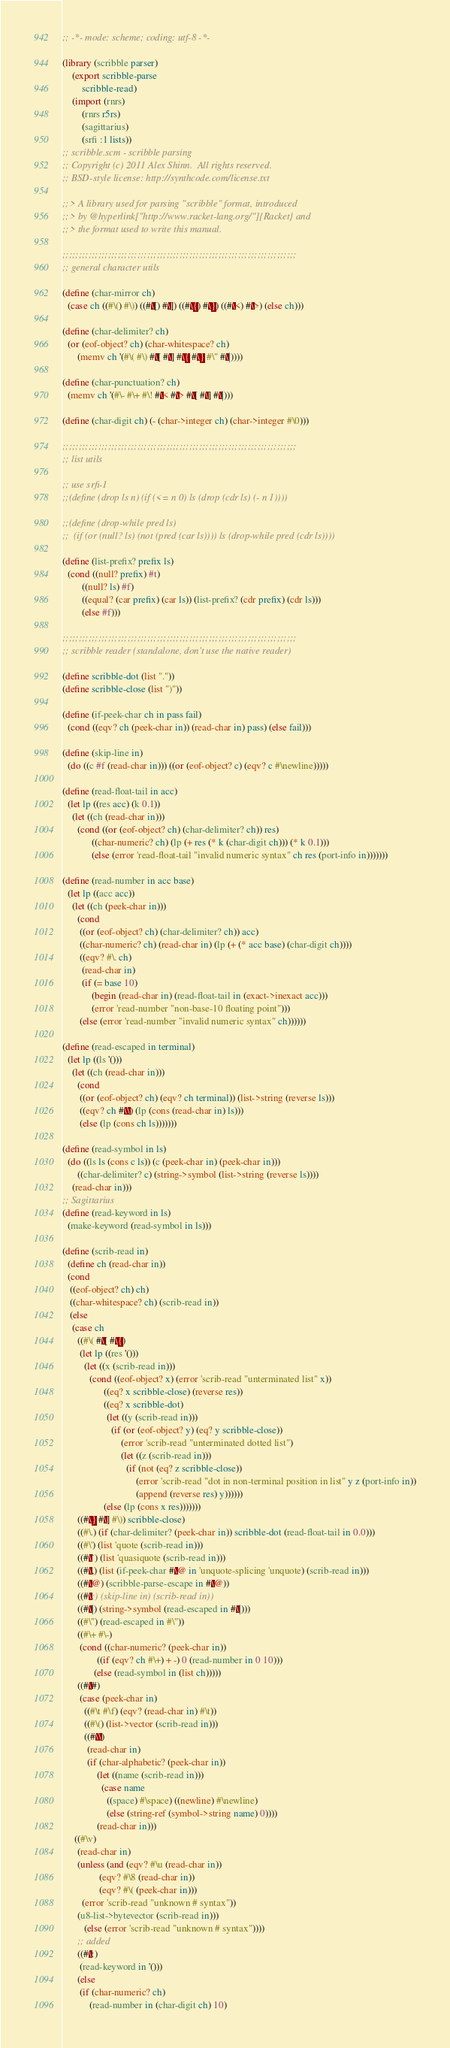<code> <loc_0><loc_0><loc_500><loc_500><_Scheme_>;; -*- mode: scheme; coding: utf-8 -*- 

(library (scribble parser)
    (export scribble-parse
	    scribble-read)
    (import (rnrs)
	    (rnrs r5rs)
	    (sagittarius)
	    (srfi :1 lists))
;; scribble.scm - scribble parsing
;; Copyright (c) 2011 Alex Shinn.  All rights reserved.
;; BSD-style license: http://synthcode.com/license.txt

;;> A library used for parsing "scribble" format, introduced
;;> by @hyperlink["http://www.racket-lang.org/"]{Racket} and
;;> the format used to write this manual.

;;;;;;;;;;;;;;;;;;;;;;;;;;;;;;;;;;;;;;;;;;;;;;;;;;;;;;;;;;;;;;;;;;;;;;;;
;; general character utils

(define (char-mirror ch)
  (case ch ((#\() #\)) ((#\[) #\]) ((#\{) #\}) ((#\<) #\>) (else ch)))

(define (char-delimiter? ch)
  (or (eof-object? ch) (char-whitespace? ch)
      (memv ch '(#\( #\) #\[ #\] #\{ #\} #\" #\|))))

(define (char-punctuation? ch)
  (memv ch '(#\- #\+ #\! #\< #\> #\[ #\] #\|)))

(define (char-digit ch) (- (char->integer ch) (char->integer #\0)))

;;;;;;;;;;;;;;;;;;;;;;;;;;;;;;;;;;;;;;;;;;;;;;;;;;;;;;;;;;;;;;;;;;;;;;;;
;; list utils

;; use srfi-1
;;(define (drop ls n) (if (<= n 0) ls (drop (cdr ls) (- n 1))))

;;(define (drop-while pred ls)
;;  (if (or (null? ls) (not (pred (car ls)))) ls (drop-while pred (cdr ls))))

(define (list-prefix? prefix ls)
  (cond ((null? prefix) #t)
        ((null? ls) #f)
        ((equal? (car prefix) (car ls)) (list-prefix? (cdr prefix) (cdr ls)))
        (else #f)))

;;;;;;;;;;;;;;;;;;;;;;;;;;;;;;;;;;;;;;;;;;;;;;;;;;;;;;;;;;;;;;;;;;;;;;;;
;; scribble reader (standalone, don't use the native reader)

(define scribble-dot (list "."))
(define scribble-close (list ")"))

(define (if-peek-char ch in pass fail)
  (cond ((eqv? ch (peek-char in)) (read-char in) pass) (else fail)))

(define (skip-line in)
  (do ((c #f (read-char in))) ((or (eof-object? c) (eqv? c #\newline)))))

(define (read-float-tail in acc)
  (let lp ((res acc) (k 0.1))
    (let ((ch (read-char in)))
      (cond ((or (eof-object? ch) (char-delimiter? ch)) res)
            ((char-numeric? ch) (lp (+ res (* k (char-digit ch))) (* k 0.1)))
            (else (error 'read-float-tail "invalid numeric syntax" ch res (port-info in)))))))

(define (read-number in acc base)
  (let lp ((acc acc))
    (let ((ch (peek-char in)))
      (cond
       ((or (eof-object? ch) (char-delimiter? ch)) acc)
       ((char-numeric? ch) (read-char in) (lp (+ (* acc base) (char-digit ch))))
       ((eqv? #\. ch)
        (read-char in)
        (if (= base 10)
            (begin (read-char in) (read-float-tail in (exact->inexact acc)))
            (error 'read-number "non-base-10 floating point")))
       (else (error 'read-number "invalid numeric syntax" ch))))))

(define (read-escaped in terminal)
  (let lp ((ls '()))
    (let ((ch (read-char in)))
      (cond
       ((or (eof-object? ch) (eqv? ch terminal)) (list->string (reverse ls)))
       ((eqv? ch #\\) (lp (cons (read-char in) ls)))
       (else (lp (cons ch ls)))))))

(define (read-symbol in ls)
  (do ((ls ls (cons c ls)) (c (peek-char in) (peek-char in)))
      ((char-delimiter? c) (string->symbol (list->string (reverse ls))))
    (read-char in)))
;; Sagittarius 
(define (read-keyword in ls)
  (make-keyword (read-symbol in ls)))

(define (scrib-read in)
  (define ch (read-char in))
  (cond
   ((eof-object? ch) ch)
   ((char-whitespace? ch) (scrib-read in))
   (else
    (case ch
      ((#\( #\[ #\{)
       (let lp ((res '()))
         (let ((x (scrib-read in)))
           (cond ((eof-object? x) (error 'scrib-read "unterminated list" x))
                 ((eq? x scribble-close) (reverse res))
                 ((eq? x scribble-dot)
                  (let ((y (scrib-read in)))
                    (if (or (eof-object? y) (eq? y scribble-close))
                        (error 'scrib-read "unterminated dotted list")
                        (let ((z (scrib-read in)))
                          (if (not (eq? z scribble-close))
                              (error 'scrib-read "dot in non-terminal position in list" y z (port-info in))
                              (append (reverse res) y))))))
                 (else (lp (cons x res)))))))
      ((#\} #\] #\)) scribble-close)
      ((#\.) (if (char-delimiter? (peek-char in)) scribble-dot (read-float-tail in 0.0)))
      ((#\') (list 'quote (scrib-read in)))
      ((#\`) (list 'quasiquote (scrib-read in)))
      ((#\,) (list (if-peek-char #\@ in 'unquote-splicing 'unquote) (scrib-read in)))
      ((#\@) (scribble-parse-escape in #\@))
      ((#\;) (skip-line in) (scrib-read in))
      ((#\|) (string->symbol (read-escaped in #\|)))
      ((#\") (read-escaped in #\"))
      ((#\+ #\-)
       (cond ((char-numeric? (peek-char in))
              ((if (eqv? ch #\+) + -) 0 (read-number in 0 10)))
             (else (read-symbol in (list ch)))))
      ((#\#)
       (case (peek-char in)
         ((#\t #\f) (eqv? (read-char in) #\t))
         ((#\() (list->vector (scrib-read in)))
         ((#\\)
          (read-char in)
          (if (char-alphabetic? (peek-char in))
              (let ((name (scrib-read in)))
                (case name
                  ((space) #\space) ((newline) #\newline)
                  (else (string-ref (symbol->string name) 0))))
              (read-char in)))
	 ((#\v)
	  (read-char in)
	  (unless (and (eqv? #\u (read-char in))
		       (eqv? #\8 (read-char in))
		       (eqv? #\( (peek-char in)))
	    (error 'scrib-read "unknown # syntax"))
	  (u8-list->bytevector (scrib-read in)))
         (else (error 'scrib-read "unknown # syntax"))))
      ;; added
      ((#\:)
       (read-keyword in '()))
      (else
       (if (char-numeric? ch)
           (read-number in (char-digit ch) 10)</code> 